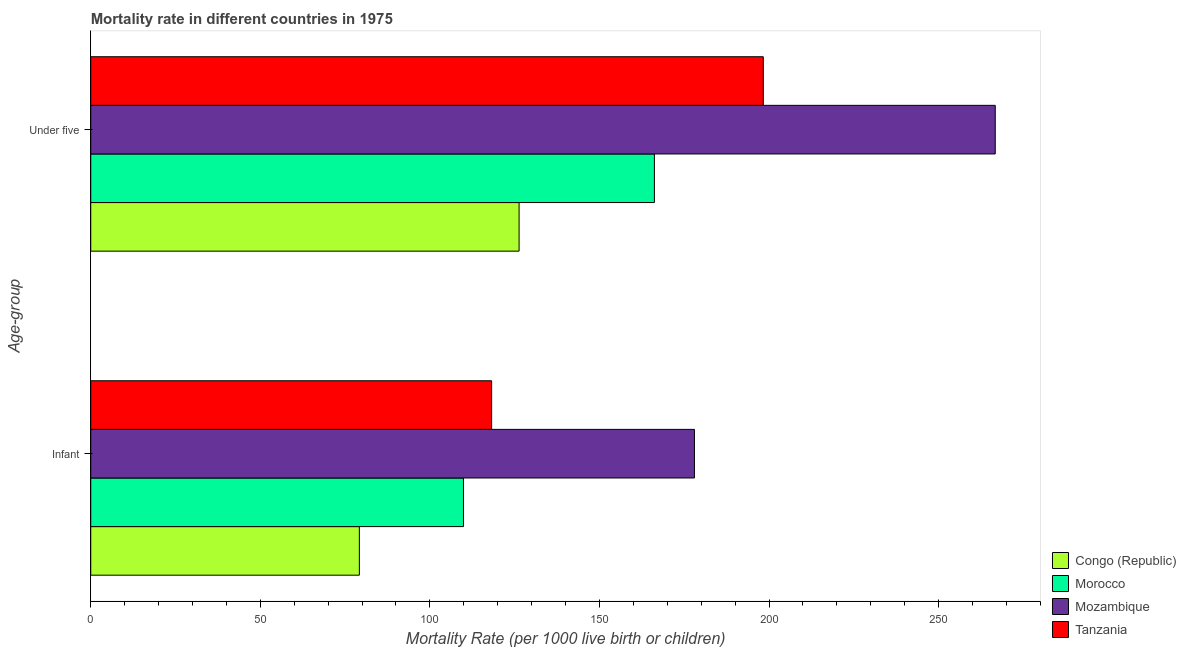What is the label of the 1st group of bars from the top?
Offer a very short reply. Under five. What is the infant mortality rate in Morocco?
Provide a short and direct response. 109.9. Across all countries, what is the maximum under-5 mortality rate?
Provide a short and direct response. 266.7. Across all countries, what is the minimum infant mortality rate?
Provide a succinct answer. 79.2. In which country was the under-5 mortality rate maximum?
Ensure brevity in your answer.  Mozambique. In which country was the under-5 mortality rate minimum?
Your response must be concise. Congo (Republic). What is the total under-5 mortality rate in the graph?
Make the answer very short. 757.5. What is the difference between the under-5 mortality rate in Mozambique and that in Tanzania?
Your response must be concise. 68.4. What is the difference between the infant mortality rate in Morocco and the under-5 mortality rate in Congo (Republic)?
Provide a succinct answer. -16.4. What is the average infant mortality rate per country?
Ensure brevity in your answer.  121.33. What is the difference between the under-5 mortality rate and infant mortality rate in Morocco?
Your response must be concise. 56.3. What is the ratio of the under-5 mortality rate in Tanzania to that in Congo (Republic)?
Ensure brevity in your answer.  1.57. What does the 2nd bar from the top in Infant represents?
Ensure brevity in your answer.  Mozambique. What does the 2nd bar from the bottom in Under five represents?
Provide a short and direct response. Morocco. How many bars are there?
Your answer should be compact. 8. Are all the bars in the graph horizontal?
Keep it short and to the point. Yes. Are the values on the major ticks of X-axis written in scientific E-notation?
Provide a short and direct response. No. Does the graph contain any zero values?
Your answer should be compact. No. Does the graph contain grids?
Ensure brevity in your answer.  No. Where does the legend appear in the graph?
Your answer should be compact. Bottom right. How many legend labels are there?
Provide a short and direct response. 4. How are the legend labels stacked?
Offer a very short reply. Vertical. What is the title of the graph?
Your answer should be compact. Mortality rate in different countries in 1975. What is the label or title of the X-axis?
Provide a succinct answer. Mortality Rate (per 1000 live birth or children). What is the label or title of the Y-axis?
Provide a short and direct response. Age-group. What is the Mortality Rate (per 1000 live birth or children) of Congo (Republic) in Infant?
Keep it short and to the point. 79.2. What is the Mortality Rate (per 1000 live birth or children) in Morocco in Infant?
Provide a short and direct response. 109.9. What is the Mortality Rate (per 1000 live birth or children) in Mozambique in Infant?
Keep it short and to the point. 178. What is the Mortality Rate (per 1000 live birth or children) in Tanzania in Infant?
Keep it short and to the point. 118.2. What is the Mortality Rate (per 1000 live birth or children) of Congo (Republic) in Under five?
Provide a short and direct response. 126.3. What is the Mortality Rate (per 1000 live birth or children) of Morocco in Under five?
Offer a very short reply. 166.2. What is the Mortality Rate (per 1000 live birth or children) of Mozambique in Under five?
Ensure brevity in your answer.  266.7. What is the Mortality Rate (per 1000 live birth or children) of Tanzania in Under five?
Offer a very short reply. 198.3. Across all Age-group, what is the maximum Mortality Rate (per 1000 live birth or children) in Congo (Republic)?
Your response must be concise. 126.3. Across all Age-group, what is the maximum Mortality Rate (per 1000 live birth or children) of Morocco?
Your answer should be very brief. 166.2. Across all Age-group, what is the maximum Mortality Rate (per 1000 live birth or children) of Mozambique?
Your answer should be compact. 266.7. Across all Age-group, what is the maximum Mortality Rate (per 1000 live birth or children) in Tanzania?
Give a very brief answer. 198.3. Across all Age-group, what is the minimum Mortality Rate (per 1000 live birth or children) of Congo (Republic)?
Provide a succinct answer. 79.2. Across all Age-group, what is the minimum Mortality Rate (per 1000 live birth or children) in Morocco?
Make the answer very short. 109.9. Across all Age-group, what is the minimum Mortality Rate (per 1000 live birth or children) in Mozambique?
Ensure brevity in your answer.  178. Across all Age-group, what is the minimum Mortality Rate (per 1000 live birth or children) in Tanzania?
Your answer should be compact. 118.2. What is the total Mortality Rate (per 1000 live birth or children) of Congo (Republic) in the graph?
Keep it short and to the point. 205.5. What is the total Mortality Rate (per 1000 live birth or children) of Morocco in the graph?
Offer a very short reply. 276.1. What is the total Mortality Rate (per 1000 live birth or children) in Mozambique in the graph?
Offer a very short reply. 444.7. What is the total Mortality Rate (per 1000 live birth or children) in Tanzania in the graph?
Give a very brief answer. 316.5. What is the difference between the Mortality Rate (per 1000 live birth or children) in Congo (Republic) in Infant and that in Under five?
Provide a short and direct response. -47.1. What is the difference between the Mortality Rate (per 1000 live birth or children) in Morocco in Infant and that in Under five?
Keep it short and to the point. -56.3. What is the difference between the Mortality Rate (per 1000 live birth or children) in Mozambique in Infant and that in Under five?
Offer a terse response. -88.7. What is the difference between the Mortality Rate (per 1000 live birth or children) of Tanzania in Infant and that in Under five?
Keep it short and to the point. -80.1. What is the difference between the Mortality Rate (per 1000 live birth or children) of Congo (Republic) in Infant and the Mortality Rate (per 1000 live birth or children) of Morocco in Under five?
Offer a terse response. -87. What is the difference between the Mortality Rate (per 1000 live birth or children) of Congo (Republic) in Infant and the Mortality Rate (per 1000 live birth or children) of Mozambique in Under five?
Keep it short and to the point. -187.5. What is the difference between the Mortality Rate (per 1000 live birth or children) of Congo (Republic) in Infant and the Mortality Rate (per 1000 live birth or children) of Tanzania in Under five?
Provide a short and direct response. -119.1. What is the difference between the Mortality Rate (per 1000 live birth or children) in Morocco in Infant and the Mortality Rate (per 1000 live birth or children) in Mozambique in Under five?
Ensure brevity in your answer.  -156.8. What is the difference between the Mortality Rate (per 1000 live birth or children) of Morocco in Infant and the Mortality Rate (per 1000 live birth or children) of Tanzania in Under five?
Offer a terse response. -88.4. What is the difference between the Mortality Rate (per 1000 live birth or children) of Mozambique in Infant and the Mortality Rate (per 1000 live birth or children) of Tanzania in Under five?
Give a very brief answer. -20.3. What is the average Mortality Rate (per 1000 live birth or children) in Congo (Republic) per Age-group?
Your answer should be very brief. 102.75. What is the average Mortality Rate (per 1000 live birth or children) in Morocco per Age-group?
Your answer should be compact. 138.05. What is the average Mortality Rate (per 1000 live birth or children) of Mozambique per Age-group?
Keep it short and to the point. 222.35. What is the average Mortality Rate (per 1000 live birth or children) in Tanzania per Age-group?
Your answer should be compact. 158.25. What is the difference between the Mortality Rate (per 1000 live birth or children) of Congo (Republic) and Mortality Rate (per 1000 live birth or children) of Morocco in Infant?
Offer a very short reply. -30.7. What is the difference between the Mortality Rate (per 1000 live birth or children) of Congo (Republic) and Mortality Rate (per 1000 live birth or children) of Mozambique in Infant?
Your answer should be compact. -98.8. What is the difference between the Mortality Rate (per 1000 live birth or children) in Congo (Republic) and Mortality Rate (per 1000 live birth or children) in Tanzania in Infant?
Your response must be concise. -39. What is the difference between the Mortality Rate (per 1000 live birth or children) of Morocco and Mortality Rate (per 1000 live birth or children) of Mozambique in Infant?
Offer a terse response. -68.1. What is the difference between the Mortality Rate (per 1000 live birth or children) in Mozambique and Mortality Rate (per 1000 live birth or children) in Tanzania in Infant?
Provide a succinct answer. 59.8. What is the difference between the Mortality Rate (per 1000 live birth or children) in Congo (Republic) and Mortality Rate (per 1000 live birth or children) in Morocco in Under five?
Give a very brief answer. -39.9. What is the difference between the Mortality Rate (per 1000 live birth or children) in Congo (Republic) and Mortality Rate (per 1000 live birth or children) in Mozambique in Under five?
Ensure brevity in your answer.  -140.4. What is the difference between the Mortality Rate (per 1000 live birth or children) in Congo (Republic) and Mortality Rate (per 1000 live birth or children) in Tanzania in Under five?
Ensure brevity in your answer.  -72. What is the difference between the Mortality Rate (per 1000 live birth or children) of Morocco and Mortality Rate (per 1000 live birth or children) of Mozambique in Under five?
Your response must be concise. -100.5. What is the difference between the Mortality Rate (per 1000 live birth or children) of Morocco and Mortality Rate (per 1000 live birth or children) of Tanzania in Under five?
Provide a short and direct response. -32.1. What is the difference between the Mortality Rate (per 1000 live birth or children) in Mozambique and Mortality Rate (per 1000 live birth or children) in Tanzania in Under five?
Ensure brevity in your answer.  68.4. What is the ratio of the Mortality Rate (per 1000 live birth or children) in Congo (Republic) in Infant to that in Under five?
Provide a succinct answer. 0.63. What is the ratio of the Mortality Rate (per 1000 live birth or children) of Morocco in Infant to that in Under five?
Offer a very short reply. 0.66. What is the ratio of the Mortality Rate (per 1000 live birth or children) of Mozambique in Infant to that in Under five?
Keep it short and to the point. 0.67. What is the ratio of the Mortality Rate (per 1000 live birth or children) of Tanzania in Infant to that in Under five?
Your response must be concise. 0.6. What is the difference between the highest and the second highest Mortality Rate (per 1000 live birth or children) of Congo (Republic)?
Your answer should be very brief. 47.1. What is the difference between the highest and the second highest Mortality Rate (per 1000 live birth or children) in Morocco?
Provide a succinct answer. 56.3. What is the difference between the highest and the second highest Mortality Rate (per 1000 live birth or children) in Mozambique?
Provide a succinct answer. 88.7. What is the difference between the highest and the second highest Mortality Rate (per 1000 live birth or children) in Tanzania?
Provide a succinct answer. 80.1. What is the difference between the highest and the lowest Mortality Rate (per 1000 live birth or children) of Congo (Republic)?
Your response must be concise. 47.1. What is the difference between the highest and the lowest Mortality Rate (per 1000 live birth or children) of Morocco?
Your answer should be compact. 56.3. What is the difference between the highest and the lowest Mortality Rate (per 1000 live birth or children) in Mozambique?
Give a very brief answer. 88.7. What is the difference between the highest and the lowest Mortality Rate (per 1000 live birth or children) of Tanzania?
Provide a short and direct response. 80.1. 